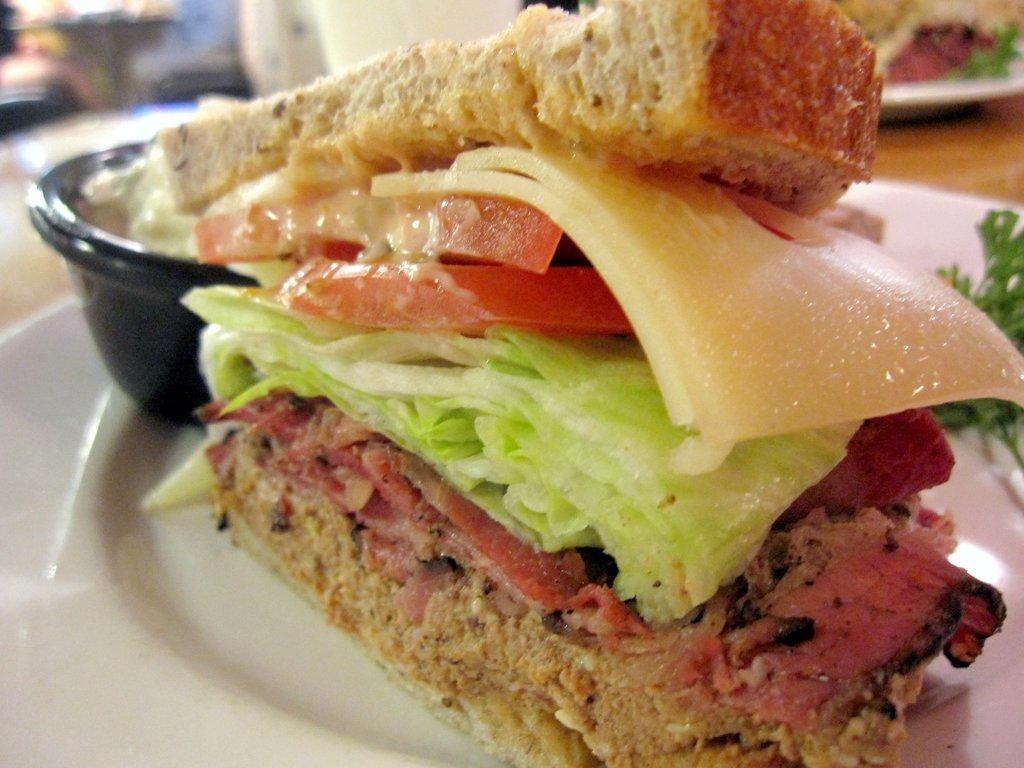In one or two sentences, can you explain what this image depicts? In this image, I can see a sandwich and a bowl on the plate. There is a blurred background. 